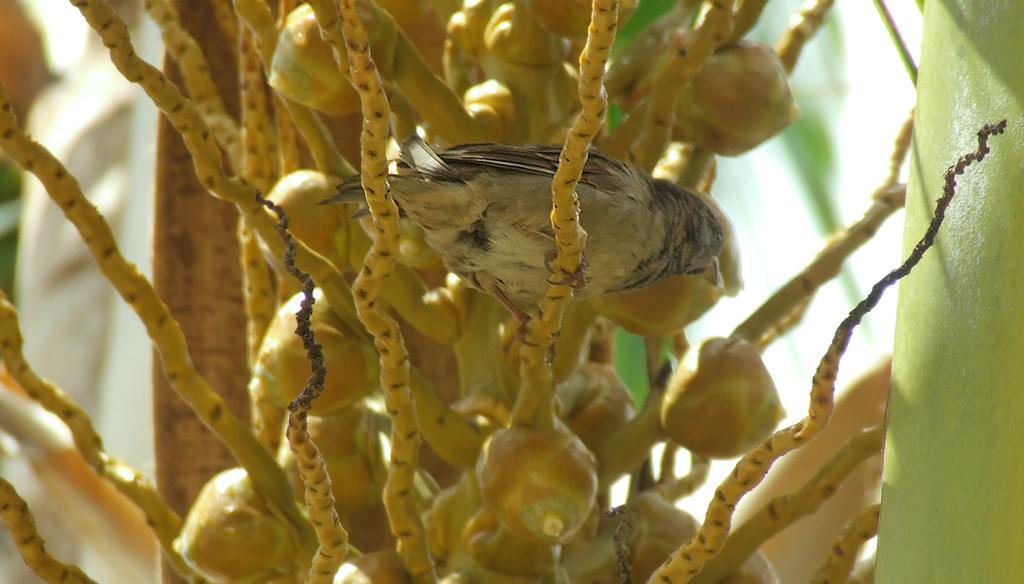Describe this image in one or two sentences. In the picture we can see a coconut tree with small coconuts in it and on it we can see a bird standing. 